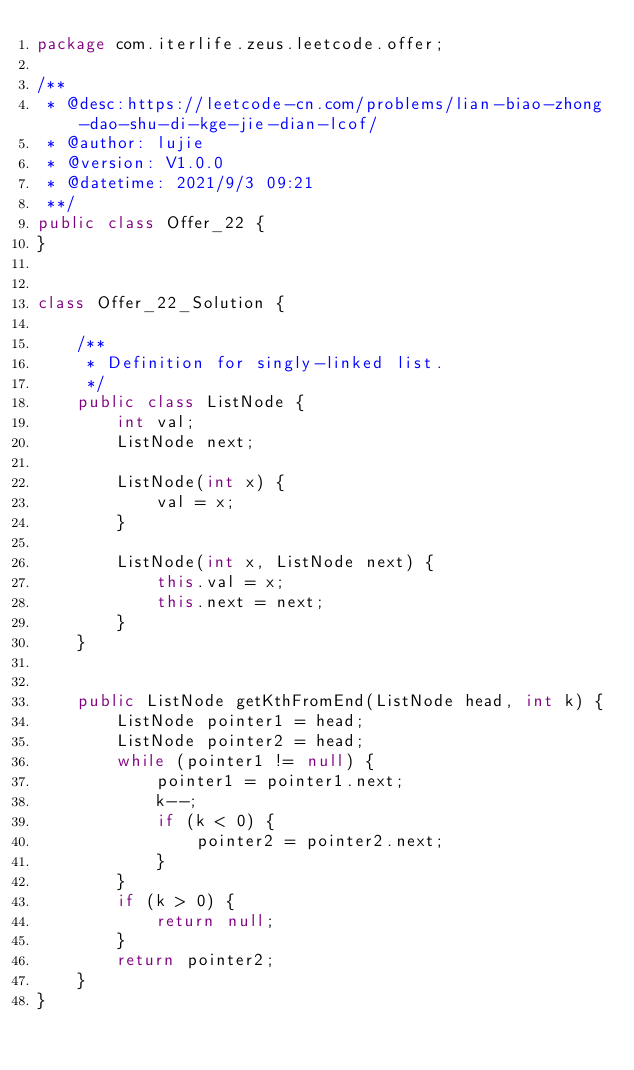<code> <loc_0><loc_0><loc_500><loc_500><_Java_>package com.iterlife.zeus.leetcode.offer;

/**
 * @desc:https://leetcode-cn.com/problems/lian-biao-zhong-dao-shu-di-kge-jie-dian-lcof/
 * @author: lujie
 * @version: V1.0.0
 * @datetime: 2021/9/3 09:21
 **/
public class Offer_22 {
}


class Offer_22_Solution {

    /**
     * Definition for singly-linked list.
     */
    public class ListNode {
        int val;
        ListNode next;

        ListNode(int x) {
            val = x;
        }

        ListNode(int x, ListNode next) {
            this.val = x;
            this.next = next;
        }
    }


    public ListNode getKthFromEnd(ListNode head, int k) {
        ListNode pointer1 = head;
        ListNode pointer2 = head;
        while (pointer1 != null) {
            pointer1 = pointer1.next;
            k--;
            if (k < 0) {
                pointer2 = pointer2.next;
            }
        }
        if (k > 0) {
            return null;
        }
        return pointer2;
    }
}</code> 